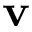Convert formula to latex. <formula><loc_0><loc_0><loc_500><loc_500>v</formula> 